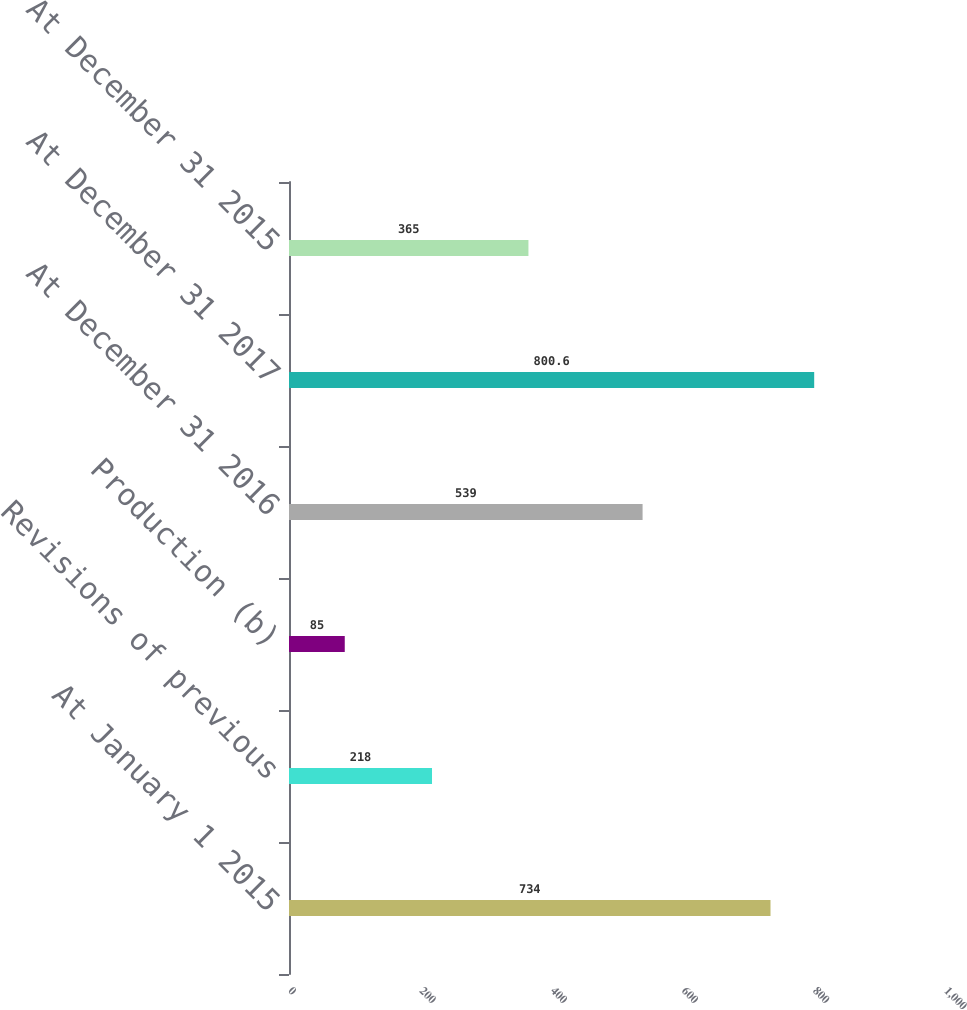Convert chart. <chart><loc_0><loc_0><loc_500><loc_500><bar_chart><fcel>At January 1 2015<fcel>Revisions of previous<fcel>Production (b)<fcel>At December 31 2016<fcel>At December 31 2017<fcel>At December 31 2015<nl><fcel>734<fcel>218<fcel>85<fcel>539<fcel>800.6<fcel>365<nl></chart> 